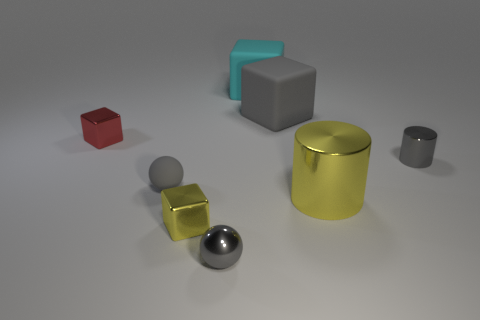There is a tiny thing to the right of the tiny object that is in front of the small yellow thing; what shape is it?
Your response must be concise. Cylinder. Is the color of the large cube in front of the big cyan thing the same as the small ball in front of the big metallic cylinder?
Give a very brief answer. Yes. Is there anything else that is the same color as the metal ball?
Give a very brief answer. Yes. The tiny cylinder has what color?
Your response must be concise. Gray. Are any large cyan things visible?
Your response must be concise. Yes. Are there any large cyan matte things behind the big cyan object?
Provide a succinct answer. No. There is a cyan object that is the same shape as the tiny red metal thing; what is it made of?
Your answer should be compact. Rubber. Is there any other thing that is the same material as the red object?
Give a very brief answer. Yes. What number of other objects are the same shape as the small yellow shiny thing?
Give a very brief answer. 3. What number of small gray things are to the right of the gray object right of the matte thing that is right of the large cyan object?
Provide a succinct answer. 0. 